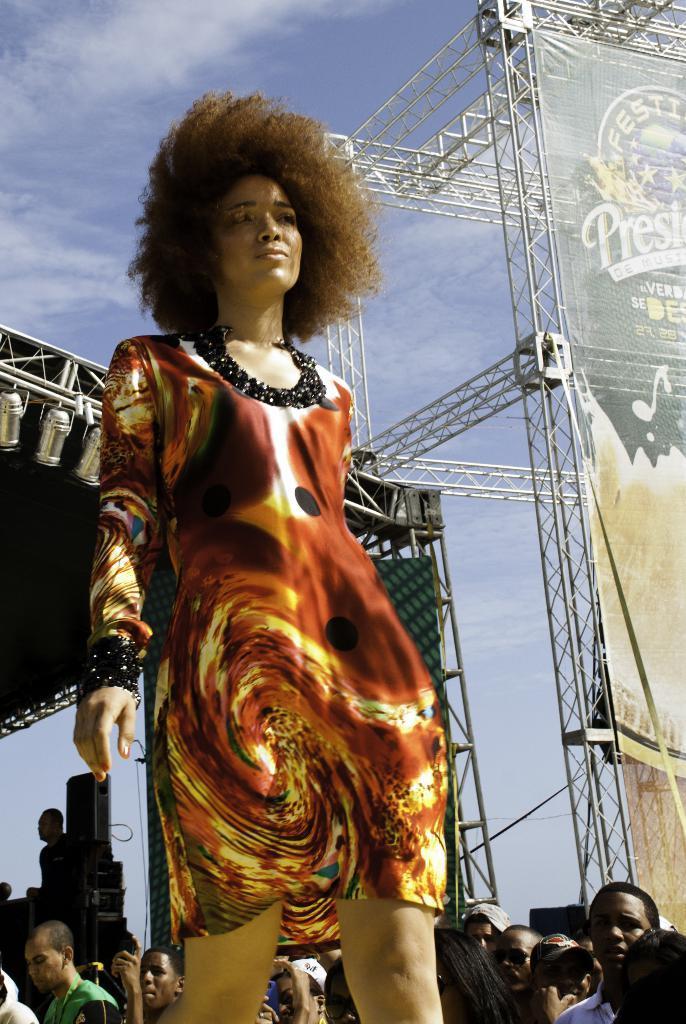In one or two sentences, can you explain what this image depicts? In this picture we can see the girl standing on the stage, wearing brown color top and giving a pose to the camera. Behind there are some people standing and looking to her. In the background there is a big advertisement hanging board on the white metal frame and some spot lights. 